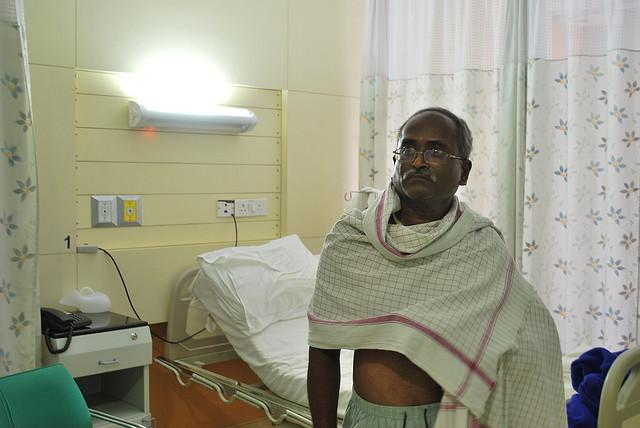This man looks most similar to what historical figure?

Choices:
A) mahatma gandhi
B) date masamune
C) cesare borgia
D) benito mussolini mahatma gandhi 